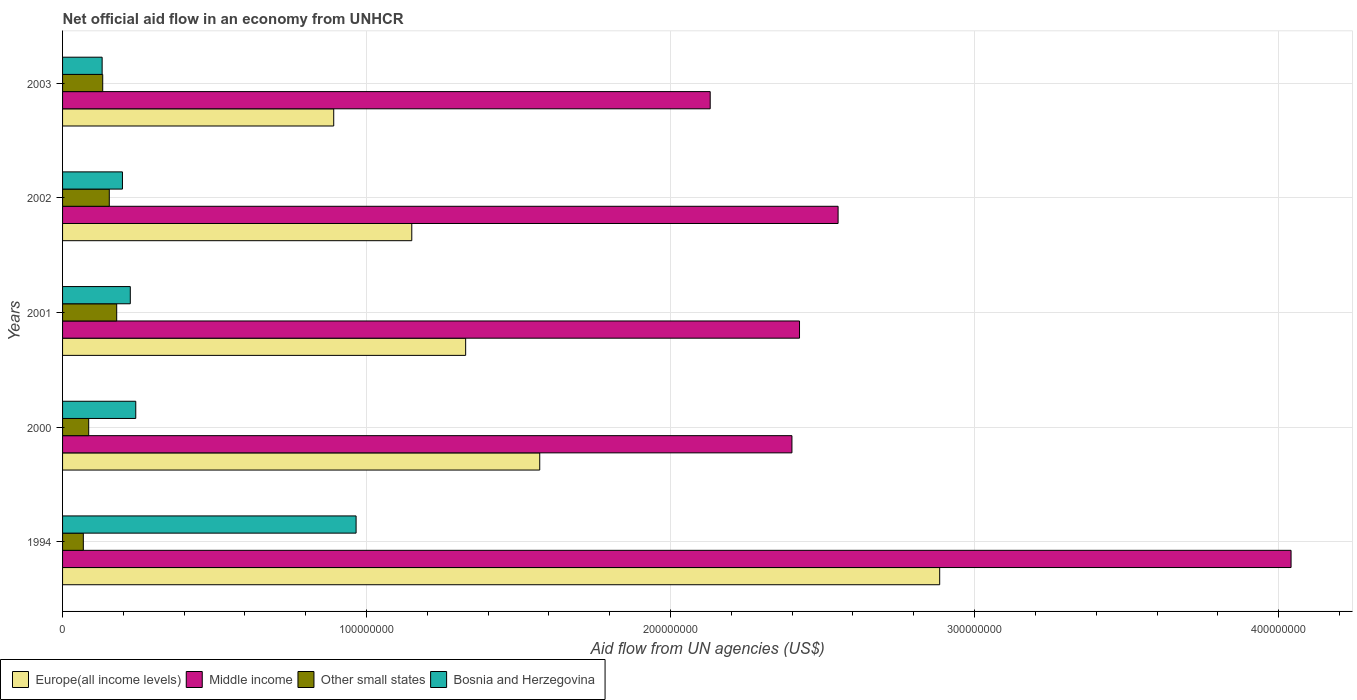How many different coloured bars are there?
Your answer should be compact. 4. In how many cases, is the number of bars for a given year not equal to the number of legend labels?
Offer a terse response. 0. What is the net official aid flow in Middle income in 2000?
Your response must be concise. 2.40e+08. Across all years, what is the maximum net official aid flow in Other small states?
Provide a short and direct response. 1.78e+07. Across all years, what is the minimum net official aid flow in Other small states?
Offer a terse response. 6.83e+06. In which year was the net official aid flow in Europe(all income levels) maximum?
Your answer should be very brief. 1994. In which year was the net official aid flow in Bosnia and Herzegovina minimum?
Your answer should be very brief. 2003. What is the total net official aid flow in Other small states in the graph?
Your answer should be very brief. 6.18e+07. What is the difference between the net official aid flow in Other small states in 1994 and that in 2003?
Your answer should be compact. -6.38e+06. What is the difference between the net official aid flow in Europe(all income levels) in 2000 and the net official aid flow in Middle income in 2002?
Offer a terse response. -9.81e+07. What is the average net official aid flow in Europe(all income levels) per year?
Offer a terse response. 1.56e+08. In the year 2001, what is the difference between the net official aid flow in Middle income and net official aid flow in Bosnia and Herzegovina?
Your answer should be very brief. 2.20e+08. In how many years, is the net official aid flow in Other small states greater than 280000000 US$?
Offer a terse response. 0. What is the ratio of the net official aid flow in Bosnia and Herzegovina in 2001 to that in 2003?
Keep it short and to the point. 1.71. Is the net official aid flow in Other small states in 2000 less than that in 2003?
Your response must be concise. Yes. Is the difference between the net official aid flow in Middle income in 2002 and 2003 greater than the difference between the net official aid flow in Bosnia and Herzegovina in 2002 and 2003?
Provide a succinct answer. Yes. What is the difference between the highest and the second highest net official aid flow in Bosnia and Herzegovina?
Ensure brevity in your answer.  7.25e+07. What is the difference between the highest and the lowest net official aid flow in Europe(all income levels)?
Keep it short and to the point. 1.99e+08. In how many years, is the net official aid flow in Europe(all income levels) greater than the average net official aid flow in Europe(all income levels) taken over all years?
Keep it short and to the point. 2. Is it the case that in every year, the sum of the net official aid flow in Bosnia and Herzegovina and net official aid flow in Other small states is greater than the sum of net official aid flow in Europe(all income levels) and net official aid flow in Middle income?
Provide a succinct answer. No. What does the 1st bar from the top in 1994 represents?
Offer a very short reply. Bosnia and Herzegovina. What does the 4th bar from the bottom in 2003 represents?
Offer a terse response. Bosnia and Herzegovina. Is it the case that in every year, the sum of the net official aid flow in Europe(all income levels) and net official aid flow in Other small states is greater than the net official aid flow in Middle income?
Give a very brief answer. No. How many bars are there?
Your answer should be compact. 20. Are all the bars in the graph horizontal?
Your answer should be compact. Yes. Does the graph contain any zero values?
Give a very brief answer. No. Does the graph contain grids?
Provide a short and direct response. Yes. What is the title of the graph?
Offer a terse response. Net official aid flow in an economy from UNHCR. Does "Equatorial Guinea" appear as one of the legend labels in the graph?
Give a very brief answer. No. What is the label or title of the X-axis?
Ensure brevity in your answer.  Aid flow from UN agencies (US$). What is the label or title of the Y-axis?
Make the answer very short. Years. What is the Aid flow from UN agencies (US$) in Europe(all income levels) in 1994?
Your answer should be very brief. 2.89e+08. What is the Aid flow from UN agencies (US$) in Middle income in 1994?
Keep it short and to the point. 4.04e+08. What is the Aid flow from UN agencies (US$) in Other small states in 1994?
Your answer should be compact. 6.83e+06. What is the Aid flow from UN agencies (US$) of Bosnia and Herzegovina in 1994?
Your answer should be very brief. 9.66e+07. What is the Aid flow from UN agencies (US$) in Europe(all income levels) in 2000?
Provide a short and direct response. 1.57e+08. What is the Aid flow from UN agencies (US$) in Middle income in 2000?
Provide a succinct answer. 2.40e+08. What is the Aid flow from UN agencies (US$) in Other small states in 2000?
Your answer should be compact. 8.60e+06. What is the Aid flow from UN agencies (US$) of Bosnia and Herzegovina in 2000?
Offer a terse response. 2.41e+07. What is the Aid flow from UN agencies (US$) of Europe(all income levels) in 2001?
Offer a terse response. 1.33e+08. What is the Aid flow from UN agencies (US$) of Middle income in 2001?
Your answer should be compact. 2.42e+08. What is the Aid flow from UN agencies (US$) in Other small states in 2001?
Give a very brief answer. 1.78e+07. What is the Aid flow from UN agencies (US$) of Bosnia and Herzegovina in 2001?
Keep it short and to the point. 2.23e+07. What is the Aid flow from UN agencies (US$) of Europe(all income levels) in 2002?
Keep it short and to the point. 1.15e+08. What is the Aid flow from UN agencies (US$) of Middle income in 2002?
Keep it short and to the point. 2.55e+08. What is the Aid flow from UN agencies (US$) of Other small states in 2002?
Provide a short and direct response. 1.54e+07. What is the Aid flow from UN agencies (US$) of Bosnia and Herzegovina in 2002?
Provide a short and direct response. 1.97e+07. What is the Aid flow from UN agencies (US$) of Europe(all income levels) in 2003?
Offer a very short reply. 8.92e+07. What is the Aid flow from UN agencies (US$) in Middle income in 2003?
Make the answer very short. 2.13e+08. What is the Aid flow from UN agencies (US$) of Other small states in 2003?
Give a very brief answer. 1.32e+07. What is the Aid flow from UN agencies (US$) in Bosnia and Herzegovina in 2003?
Your answer should be compact. 1.30e+07. Across all years, what is the maximum Aid flow from UN agencies (US$) in Europe(all income levels)?
Keep it short and to the point. 2.89e+08. Across all years, what is the maximum Aid flow from UN agencies (US$) of Middle income?
Your response must be concise. 4.04e+08. Across all years, what is the maximum Aid flow from UN agencies (US$) in Other small states?
Keep it short and to the point. 1.78e+07. Across all years, what is the maximum Aid flow from UN agencies (US$) in Bosnia and Herzegovina?
Your answer should be very brief. 9.66e+07. Across all years, what is the minimum Aid flow from UN agencies (US$) in Europe(all income levels)?
Give a very brief answer. 8.92e+07. Across all years, what is the minimum Aid flow from UN agencies (US$) in Middle income?
Your answer should be compact. 2.13e+08. Across all years, what is the minimum Aid flow from UN agencies (US$) of Other small states?
Make the answer very short. 6.83e+06. Across all years, what is the minimum Aid flow from UN agencies (US$) of Bosnia and Herzegovina?
Give a very brief answer. 1.30e+07. What is the total Aid flow from UN agencies (US$) of Europe(all income levels) in the graph?
Your response must be concise. 7.82e+08. What is the total Aid flow from UN agencies (US$) of Middle income in the graph?
Your answer should be compact. 1.35e+09. What is the total Aid flow from UN agencies (US$) in Other small states in the graph?
Your answer should be compact. 6.18e+07. What is the total Aid flow from UN agencies (US$) of Bosnia and Herzegovina in the graph?
Offer a very short reply. 1.76e+08. What is the difference between the Aid flow from UN agencies (US$) in Europe(all income levels) in 1994 and that in 2000?
Your answer should be very brief. 1.32e+08. What is the difference between the Aid flow from UN agencies (US$) in Middle income in 1994 and that in 2000?
Ensure brevity in your answer.  1.64e+08. What is the difference between the Aid flow from UN agencies (US$) of Other small states in 1994 and that in 2000?
Ensure brevity in your answer.  -1.77e+06. What is the difference between the Aid flow from UN agencies (US$) in Bosnia and Herzegovina in 1994 and that in 2000?
Your answer should be compact. 7.25e+07. What is the difference between the Aid flow from UN agencies (US$) of Europe(all income levels) in 1994 and that in 2001?
Provide a short and direct response. 1.56e+08. What is the difference between the Aid flow from UN agencies (US$) in Middle income in 1994 and that in 2001?
Your answer should be very brief. 1.62e+08. What is the difference between the Aid flow from UN agencies (US$) of Other small states in 1994 and that in 2001?
Your answer should be compact. -1.10e+07. What is the difference between the Aid flow from UN agencies (US$) in Bosnia and Herzegovina in 1994 and that in 2001?
Give a very brief answer. 7.43e+07. What is the difference between the Aid flow from UN agencies (US$) of Europe(all income levels) in 1994 and that in 2002?
Your answer should be very brief. 1.74e+08. What is the difference between the Aid flow from UN agencies (US$) of Middle income in 1994 and that in 2002?
Your answer should be very brief. 1.49e+08. What is the difference between the Aid flow from UN agencies (US$) in Other small states in 1994 and that in 2002?
Your response must be concise. -8.54e+06. What is the difference between the Aid flow from UN agencies (US$) of Bosnia and Herzegovina in 1994 and that in 2002?
Offer a very short reply. 7.68e+07. What is the difference between the Aid flow from UN agencies (US$) of Europe(all income levels) in 1994 and that in 2003?
Make the answer very short. 1.99e+08. What is the difference between the Aid flow from UN agencies (US$) of Middle income in 1994 and that in 2003?
Offer a very short reply. 1.91e+08. What is the difference between the Aid flow from UN agencies (US$) of Other small states in 1994 and that in 2003?
Provide a succinct answer. -6.38e+06. What is the difference between the Aid flow from UN agencies (US$) of Bosnia and Herzegovina in 1994 and that in 2003?
Offer a terse response. 8.35e+07. What is the difference between the Aid flow from UN agencies (US$) of Europe(all income levels) in 2000 and that in 2001?
Make the answer very short. 2.44e+07. What is the difference between the Aid flow from UN agencies (US$) of Middle income in 2000 and that in 2001?
Your answer should be compact. -2.49e+06. What is the difference between the Aid flow from UN agencies (US$) of Other small states in 2000 and that in 2001?
Make the answer very short. -9.21e+06. What is the difference between the Aid flow from UN agencies (US$) of Bosnia and Herzegovina in 2000 and that in 2001?
Provide a succinct answer. 1.80e+06. What is the difference between the Aid flow from UN agencies (US$) in Europe(all income levels) in 2000 and that in 2002?
Your answer should be very brief. 4.21e+07. What is the difference between the Aid flow from UN agencies (US$) in Middle income in 2000 and that in 2002?
Keep it short and to the point. -1.52e+07. What is the difference between the Aid flow from UN agencies (US$) of Other small states in 2000 and that in 2002?
Your answer should be very brief. -6.77e+06. What is the difference between the Aid flow from UN agencies (US$) of Bosnia and Herzegovina in 2000 and that in 2002?
Keep it short and to the point. 4.38e+06. What is the difference between the Aid flow from UN agencies (US$) in Europe(all income levels) in 2000 and that in 2003?
Provide a short and direct response. 6.78e+07. What is the difference between the Aid flow from UN agencies (US$) in Middle income in 2000 and that in 2003?
Give a very brief answer. 2.69e+07. What is the difference between the Aid flow from UN agencies (US$) of Other small states in 2000 and that in 2003?
Keep it short and to the point. -4.61e+06. What is the difference between the Aid flow from UN agencies (US$) of Bosnia and Herzegovina in 2000 and that in 2003?
Keep it short and to the point. 1.11e+07. What is the difference between the Aid flow from UN agencies (US$) of Europe(all income levels) in 2001 and that in 2002?
Keep it short and to the point. 1.77e+07. What is the difference between the Aid flow from UN agencies (US$) in Middle income in 2001 and that in 2002?
Your response must be concise. -1.27e+07. What is the difference between the Aid flow from UN agencies (US$) of Other small states in 2001 and that in 2002?
Offer a terse response. 2.44e+06. What is the difference between the Aid flow from UN agencies (US$) of Bosnia and Herzegovina in 2001 and that in 2002?
Offer a very short reply. 2.58e+06. What is the difference between the Aid flow from UN agencies (US$) in Europe(all income levels) in 2001 and that in 2003?
Offer a very short reply. 4.34e+07. What is the difference between the Aid flow from UN agencies (US$) in Middle income in 2001 and that in 2003?
Give a very brief answer. 2.94e+07. What is the difference between the Aid flow from UN agencies (US$) of Other small states in 2001 and that in 2003?
Your answer should be very brief. 4.60e+06. What is the difference between the Aid flow from UN agencies (US$) in Bosnia and Herzegovina in 2001 and that in 2003?
Ensure brevity in your answer.  9.26e+06. What is the difference between the Aid flow from UN agencies (US$) in Europe(all income levels) in 2002 and that in 2003?
Your answer should be very brief. 2.57e+07. What is the difference between the Aid flow from UN agencies (US$) of Middle income in 2002 and that in 2003?
Your response must be concise. 4.21e+07. What is the difference between the Aid flow from UN agencies (US$) of Other small states in 2002 and that in 2003?
Keep it short and to the point. 2.16e+06. What is the difference between the Aid flow from UN agencies (US$) in Bosnia and Herzegovina in 2002 and that in 2003?
Give a very brief answer. 6.68e+06. What is the difference between the Aid flow from UN agencies (US$) of Europe(all income levels) in 1994 and the Aid flow from UN agencies (US$) of Middle income in 2000?
Give a very brief answer. 4.86e+07. What is the difference between the Aid flow from UN agencies (US$) in Europe(all income levels) in 1994 and the Aid flow from UN agencies (US$) in Other small states in 2000?
Give a very brief answer. 2.80e+08. What is the difference between the Aid flow from UN agencies (US$) of Europe(all income levels) in 1994 and the Aid flow from UN agencies (US$) of Bosnia and Herzegovina in 2000?
Your response must be concise. 2.64e+08. What is the difference between the Aid flow from UN agencies (US$) in Middle income in 1994 and the Aid flow from UN agencies (US$) in Other small states in 2000?
Provide a short and direct response. 3.96e+08. What is the difference between the Aid flow from UN agencies (US$) in Middle income in 1994 and the Aid flow from UN agencies (US$) in Bosnia and Herzegovina in 2000?
Provide a succinct answer. 3.80e+08. What is the difference between the Aid flow from UN agencies (US$) of Other small states in 1994 and the Aid flow from UN agencies (US$) of Bosnia and Herzegovina in 2000?
Keep it short and to the point. -1.72e+07. What is the difference between the Aid flow from UN agencies (US$) of Europe(all income levels) in 1994 and the Aid flow from UN agencies (US$) of Middle income in 2001?
Provide a succinct answer. 4.61e+07. What is the difference between the Aid flow from UN agencies (US$) in Europe(all income levels) in 1994 and the Aid flow from UN agencies (US$) in Other small states in 2001?
Offer a very short reply. 2.71e+08. What is the difference between the Aid flow from UN agencies (US$) of Europe(all income levels) in 1994 and the Aid flow from UN agencies (US$) of Bosnia and Herzegovina in 2001?
Give a very brief answer. 2.66e+08. What is the difference between the Aid flow from UN agencies (US$) of Middle income in 1994 and the Aid flow from UN agencies (US$) of Other small states in 2001?
Give a very brief answer. 3.86e+08. What is the difference between the Aid flow from UN agencies (US$) of Middle income in 1994 and the Aid flow from UN agencies (US$) of Bosnia and Herzegovina in 2001?
Your response must be concise. 3.82e+08. What is the difference between the Aid flow from UN agencies (US$) in Other small states in 1994 and the Aid flow from UN agencies (US$) in Bosnia and Herzegovina in 2001?
Give a very brief answer. -1.54e+07. What is the difference between the Aid flow from UN agencies (US$) of Europe(all income levels) in 1994 and the Aid flow from UN agencies (US$) of Middle income in 2002?
Keep it short and to the point. 3.34e+07. What is the difference between the Aid flow from UN agencies (US$) of Europe(all income levels) in 1994 and the Aid flow from UN agencies (US$) of Other small states in 2002?
Your response must be concise. 2.73e+08. What is the difference between the Aid flow from UN agencies (US$) in Europe(all income levels) in 1994 and the Aid flow from UN agencies (US$) in Bosnia and Herzegovina in 2002?
Your response must be concise. 2.69e+08. What is the difference between the Aid flow from UN agencies (US$) of Middle income in 1994 and the Aid flow from UN agencies (US$) of Other small states in 2002?
Keep it short and to the point. 3.89e+08. What is the difference between the Aid flow from UN agencies (US$) of Middle income in 1994 and the Aid flow from UN agencies (US$) of Bosnia and Herzegovina in 2002?
Offer a very short reply. 3.84e+08. What is the difference between the Aid flow from UN agencies (US$) of Other small states in 1994 and the Aid flow from UN agencies (US$) of Bosnia and Herzegovina in 2002?
Provide a short and direct response. -1.29e+07. What is the difference between the Aid flow from UN agencies (US$) of Europe(all income levels) in 1994 and the Aid flow from UN agencies (US$) of Middle income in 2003?
Your answer should be compact. 7.55e+07. What is the difference between the Aid flow from UN agencies (US$) of Europe(all income levels) in 1994 and the Aid flow from UN agencies (US$) of Other small states in 2003?
Ensure brevity in your answer.  2.75e+08. What is the difference between the Aid flow from UN agencies (US$) in Europe(all income levels) in 1994 and the Aid flow from UN agencies (US$) in Bosnia and Herzegovina in 2003?
Offer a terse response. 2.76e+08. What is the difference between the Aid flow from UN agencies (US$) in Middle income in 1994 and the Aid flow from UN agencies (US$) in Other small states in 2003?
Make the answer very short. 3.91e+08. What is the difference between the Aid flow from UN agencies (US$) of Middle income in 1994 and the Aid flow from UN agencies (US$) of Bosnia and Herzegovina in 2003?
Give a very brief answer. 3.91e+08. What is the difference between the Aid flow from UN agencies (US$) in Other small states in 1994 and the Aid flow from UN agencies (US$) in Bosnia and Herzegovina in 2003?
Provide a short and direct response. -6.19e+06. What is the difference between the Aid flow from UN agencies (US$) in Europe(all income levels) in 2000 and the Aid flow from UN agencies (US$) in Middle income in 2001?
Ensure brevity in your answer.  -8.54e+07. What is the difference between the Aid flow from UN agencies (US$) of Europe(all income levels) in 2000 and the Aid flow from UN agencies (US$) of Other small states in 2001?
Ensure brevity in your answer.  1.39e+08. What is the difference between the Aid flow from UN agencies (US$) of Europe(all income levels) in 2000 and the Aid flow from UN agencies (US$) of Bosnia and Herzegovina in 2001?
Your answer should be very brief. 1.35e+08. What is the difference between the Aid flow from UN agencies (US$) in Middle income in 2000 and the Aid flow from UN agencies (US$) in Other small states in 2001?
Your response must be concise. 2.22e+08. What is the difference between the Aid flow from UN agencies (US$) in Middle income in 2000 and the Aid flow from UN agencies (US$) in Bosnia and Herzegovina in 2001?
Your answer should be compact. 2.18e+08. What is the difference between the Aid flow from UN agencies (US$) of Other small states in 2000 and the Aid flow from UN agencies (US$) of Bosnia and Herzegovina in 2001?
Give a very brief answer. -1.37e+07. What is the difference between the Aid flow from UN agencies (US$) of Europe(all income levels) in 2000 and the Aid flow from UN agencies (US$) of Middle income in 2002?
Provide a succinct answer. -9.81e+07. What is the difference between the Aid flow from UN agencies (US$) of Europe(all income levels) in 2000 and the Aid flow from UN agencies (US$) of Other small states in 2002?
Make the answer very short. 1.42e+08. What is the difference between the Aid flow from UN agencies (US$) of Europe(all income levels) in 2000 and the Aid flow from UN agencies (US$) of Bosnia and Herzegovina in 2002?
Provide a short and direct response. 1.37e+08. What is the difference between the Aid flow from UN agencies (US$) in Middle income in 2000 and the Aid flow from UN agencies (US$) in Other small states in 2002?
Ensure brevity in your answer.  2.25e+08. What is the difference between the Aid flow from UN agencies (US$) of Middle income in 2000 and the Aid flow from UN agencies (US$) of Bosnia and Herzegovina in 2002?
Make the answer very short. 2.20e+08. What is the difference between the Aid flow from UN agencies (US$) of Other small states in 2000 and the Aid flow from UN agencies (US$) of Bosnia and Herzegovina in 2002?
Your answer should be compact. -1.11e+07. What is the difference between the Aid flow from UN agencies (US$) in Europe(all income levels) in 2000 and the Aid flow from UN agencies (US$) in Middle income in 2003?
Give a very brief answer. -5.61e+07. What is the difference between the Aid flow from UN agencies (US$) of Europe(all income levels) in 2000 and the Aid flow from UN agencies (US$) of Other small states in 2003?
Offer a terse response. 1.44e+08. What is the difference between the Aid flow from UN agencies (US$) of Europe(all income levels) in 2000 and the Aid flow from UN agencies (US$) of Bosnia and Herzegovina in 2003?
Your answer should be compact. 1.44e+08. What is the difference between the Aid flow from UN agencies (US$) in Middle income in 2000 and the Aid flow from UN agencies (US$) in Other small states in 2003?
Provide a succinct answer. 2.27e+08. What is the difference between the Aid flow from UN agencies (US$) in Middle income in 2000 and the Aid flow from UN agencies (US$) in Bosnia and Herzegovina in 2003?
Ensure brevity in your answer.  2.27e+08. What is the difference between the Aid flow from UN agencies (US$) in Other small states in 2000 and the Aid flow from UN agencies (US$) in Bosnia and Herzegovina in 2003?
Provide a short and direct response. -4.42e+06. What is the difference between the Aid flow from UN agencies (US$) in Europe(all income levels) in 2001 and the Aid flow from UN agencies (US$) in Middle income in 2002?
Keep it short and to the point. -1.23e+08. What is the difference between the Aid flow from UN agencies (US$) in Europe(all income levels) in 2001 and the Aid flow from UN agencies (US$) in Other small states in 2002?
Your response must be concise. 1.17e+08. What is the difference between the Aid flow from UN agencies (US$) of Europe(all income levels) in 2001 and the Aid flow from UN agencies (US$) of Bosnia and Herzegovina in 2002?
Give a very brief answer. 1.13e+08. What is the difference between the Aid flow from UN agencies (US$) of Middle income in 2001 and the Aid flow from UN agencies (US$) of Other small states in 2002?
Ensure brevity in your answer.  2.27e+08. What is the difference between the Aid flow from UN agencies (US$) of Middle income in 2001 and the Aid flow from UN agencies (US$) of Bosnia and Herzegovina in 2002?
Provide a succinct answer. 2.23e+08. What is the difference between the Aid flow from UN agencies (US$) in Other small states in 2001 and the Aid flow from UN agencies (US$) in Bosnia and Herzegovina in 2002?
Your answer should be very brief. -1.89e+06. What is the difference between the Aid flow from UN agencies (US$) in Europe(all income levels) in 2001 and the Aid flow from UN agencies (US$) in Middle income in 2003?
Give a very brief answer. -8.04e+07. What is the difference between the Aid flow from UN agencies (US$) of Europe(all income levels) in 2001 and the Aid flow from UN agencies (US$) of Other small states in 2003?
Your answer should be compact. 1.19e+08. What is the difference between the Aid flow from UN agencies (US$) of Europe(all income levels) in 2001 and the Aid flow from UN agencies (US$) of Bosnia and Herzegovina in 2003?
Your answer should be compact. 1.20e+08. What is the difference between the Aid flow from UN agencies (US$) of Middle income in 2001 and the Aid flow from UN agencies (US$) of Other small states in 2003?
Make the answer very short. 2.29e+08. What is the difference between the Aid flow from UN agencies (US$) in Middle income in 2001 and the Aid flow from UN agencies (US$) in Bosnia and Herzegovina in 2003?
Give a very brief answer. 2.29e+08. What is the difference between the Aid flow from UN agencies (US$) of Other small states in 2001 and the Aid flow from UN agencies (US$) of Bosnia and Herzegovina in 2003?
Give a very brief answer. 4.79e+06. What is the difference between the Aid flow from UN agencies (US$) of Europe(all income levels) in 2002 and the Aid flow from UN agencies (US$) of Middle income in 2003?
Give a very brief answer. -9.82e+07. What is the difference between the Aid flow from UN agencies (US$) in Europe(all income levels) in 2002 and the Aid flow from UN agencies (US$) in Other small states in 2003?
Offer a very short reply. 1.02e+08. What is the difference between the Aid flow from UN agencies (US$) of Europe(all income levels) in 2002 and the Aid flow from UN agencies (US$) of Bosnia and Herzegovina in 2003?
Give a very brief answer. 1.02e+08. What is the difference between the Aid flow from UN agencies (US$) of Middle income in 2002 and the Aid flow from UN agencies (US$) of Other small states in 2003?
Keep it short and to the point. 2.42e+08. What is the difference between the Aid flow from UN agencies (US$) of Middle income in 2002 and the Aid flow from UN agencies (US$) of Bosnia and Herzegovina in 2003?
Give a very brief answer. 2.42e+08. What is the difference between the Aid flow from UN agencies (US$) of Other small states in 2002 and the Aid flow from UN agencies (US$) of Bosnia and Herzegovina in 2003?
Ensure brevity in your answer.  2.35e+06. What is the average Aid flow from UN agencies (US$) of Europe(all income levels) per year?
Provide a short and direct response. 1.56e+08. What is the average Aid flow from UN agencies (US$) of Middle income per year?
Offer a terse response. 2.71e+08. What is the average Aid flow from UN agencies (US$) in Other small states per year?
Offer a very short reply. 1.24e+07. What is the average Aid flow from UN agencies (US$) of Bosnia and Herzegovina per year?
Keep it short and to the point. 3.51e+07. In the year 1994, what is the difference between the Aid flow from UN agencies (US$) in Europe(all income levels) and Aid flow from UN agencies (US$) in Middle income?
Give a very brief answer. -1.16e+08. In the year 1994, what is the difference between the Aid flow from UN agencies (US$) of Europe(all income levels) and Aid flow from UN agencies (US$) of Other small states?
Keep it short and to the point. 2.82e+08. In the year 1994, what is the difference between the Aid flow from UN agencies (US$) of Europe(all income levels) and Aid flow from UN agencies (US$) of Bosnia and Herzegovina?
Provide a succinct answer. 1.92e+08. In the year 1994, what is the difference between the Aid flow from UN agencies (US$) of Middle income and Aid flow from UN agencies (US$) of Other small states?
Make the answer very short. 3.97e+08. In the year 1994, what is the difference between the Aid flow from UN agencies (US$) in Middle income and Aid flow from UN agencies (US$) in Bosnia and Herzegovina?
Your answer should be very brief. 3.08e+08. In the year 1994, what is the difference between the Aid flow from UN agencies (US$) of Other small states and Aid flow from UN agencies (US$) of Bosnia and Herzegovina?
Make the answer very short. -8.97e+07. In the year 2000, what is the difference between the Aid flow from UN agencies (US$) of Europe(all income levels) and Aid flow from UN agencies (US$) of Middle income?
Provide a succinct answer. -8.30e+07. In the year 2000, what is the difference between the Aid flow from UN agencies (US$) in Europe(all income levels) and Aid flow from UN agencies (US$) in Other small states?
Offer a terse response. 1.48e+08. In the year 2000, what is the difference between the Aid flow from UN agencies (US$) in Europe(all income levels) and Aid flow from UN agencies (US$) in Bosnia and Herzegovina?
Make the answer very short. 1.33e+08. In the year 2000, what is the difference between the Aid flow from UN agencies (US$) of Middle income and Aid flow from UN agencies (US$) of Other small states?
Offer a very short reply. 2.31e+08. In the year 2000, what is the difference between the Aid flow from UN agencies (US$) of Middle income and Aid flow from UN agencies (US$) of Bosnia and Herzegovina?
Make the answer very short. 2.16e+08. In the year 2000, what is the difference between the Aid flow from UN agencies (US$) of Other small states and Aid flow from UN agencies (US$) of Bosnia and Herzegovina?
Ensure brevity in your answer.  -1.55e+07. In the year 2001, what is the difference between the Aid flow from UN agencies (US$) in Europe(all income levels) and Aid flow from UN agencies (US$) in Middle income?
Your answer should be compact. -1.10e+08. In the year 2001, what is the difference between the Aid flow from UN agencies (US$) of Europe(all income levels) and Aid flow from UN agencies (US$) of Other small states?
Your answer should be very brief. 1.15e+08. In the year 2001, what is the difference between the Aid flow from UN agencies (US$) in Europe(all income levels) and Aid flow from UN agencies (US$) in Bosnia and Herzegovina?
Provide a short and direct response. 1.10e+08. In the year 2001, what is the difference between the Aid flow from UN agencies (US$) of Middle income and Aid flow from UN agencies (US$) of Other small states?
Your answer should be very brief. 2.25e+08. In the year 2001, what is the difference between the Aid flow from UN agencies (US$) of Middle income and Aid flow from UN agencies (US$) of Bosnia and Herzegovina?
Keep it short and to the point. 2.20e+08. In the year 2001, what is the difference between the Aid flow from UN agencies (US$) of Other small states and Aid flow from UN agencies (US$) of Bosnia and Herzegovina?
Offer a very short reply. -4.47e+06. In the year 2002, what is the difference between the Aid flow from UN agencies (US$) in Europe(all income levels) and Aid flow from UN agencies (US$) in Middle income?
Your response must be concise. -1.40e+08. In the year 2002, what is the difference between the Aid flow from UN agencies (US$) in Europe(all income levels) and Aid flow from UN agencies (US$) in Other small states?
Your answer should be compact. 9.95e+07. In the year 2002, what is the difference between the Aid flow from UN agencies (US$) of Europe(all income levels) and Aid flow from UN agencies (US$) of Bosnia and Herzegovina?
Make the answer very short. 9.52e+07. In the year 2002, what is the difference between the Aid flow from UN agencies (US$) in Middle income and Aid flow from UN agencies (US$) in Other small states?
Provide a succinct answer. 2.40e+08. In the year 2002, what is the difference between the Aid flow from UN agencies (US$) in Middle income and Aid flow from UN agencies (US$) in Bosnia and Herzegovina?
Your response must be concise. 2.35e+08. In the year 2002, what is the difference between the Aid flow from UN agencies (US$) of Other small states and Aid flow from UN agencies (US$) of Bosnia and Herzegovina?
Offer a very short reply. -4.33e+06. In the year 2003, what is the difference between the Aid flow from UN agencies (US$) in Europe(all income levels) and Aid flow from UN agencies (US$) in Middle income?
Ensure brevity in your answer.  -1.24e+08. In the year 2003, what is the difference between the Aid flow from UN agencies (US$) of Europe(all income levels) and Aid flow from UN agencies (US$) of Other small states?
Your answer should be compact. 7.60e+07. In the year 2003, what is the difference between the Aid flow from UN agencies (US$) in Europe(all income levels) and Aid flow from UN agencies (US$) in Bosnia and Herzegovina?
Give a very brief answer. 7.62e+07. In the year 2003, what is the difference between the Aid flow from UN agencies (US$) of Middle income and Aid flow from UN agencies (US$) of Other small states?
Your answer should be very brief. 2.00e+08. In the year 2003, what is the difference between the Aid flow from UN agencies (US$) in Middle income and Aid flow from UN agencies (US$) in Bosnia and Herzegovina?
Give a very brief answer. 2.00e+08. In the year 2003, what is the difference between the Aid flow from UN agencies (US$) in Other small states and Aid flow from UN agencies (US$) in Bosnia and Herzegovina?
Your response must be concise. 1.90e+05. What is the ratio of the Aid flow from UN agencies (US$) of Europe(all income levels) in 1994 to that in 2000?
Ensure brevity in your answer.  1.84. What is the ratio of the Aid flow from UN agencies (US$) in Middle income in 1994 to that in 2000?
Keep it short and to the point. 1.68. What is the ratio of the Aid flow from UN agencies (US$) in Other small states in 1994 to that in 2000?
Your answer should be compact. 0.79. What is the ratio of the Aid flow from UN agencies (US$) of Bosnia and Herzegovina in 1994 to that in 2000?
Ensure brevity in your answer.  4.01. What is the ratio of the Aid flow from UN agencies (US$) in Europe(all income levels) in 1994 to that in 2001?
Provide a succinct answer. 2.18. What is the ratio of the Aid flow from UN agencies (US$) in Middle income in 1994 to that in 2001?
Offer a very short reply. 1.67. What is the ratio of the Aid flow from UN agencies (US$) of Other small states in 1994 to that in 2001?
Keep it short and to the point. 0.38. What is the ratio of the Aid flow from UN agencies (US$) in Bosnia and Herzegovina in 1994 to that in 2001?
Keep it short and to the point. 4.33. What is the ratio of the Aid flow from UN agencies (US$) of Europe(all income levels) in 1994 to that in 2002?
Provide a succinct answer. 2.51. What is the ratio of the Aid flow from UN agencies (US$) in Middle income in 1994 to that in 2002?
Provide a short and direct response. 1.58. What is the ratio of the Aid flow from UN agencies (US$) in Other small states in 1994 to that in 2002?
Give a very brief answer. 0.44. What is the ratio of the Aid flow from UN agencies (US$) in Bosnia and Herzegovina in 1994 to that in 2002?
Offer a very short reply. 4.9. What is the ratio of the Aid flow from UN agencies (US$) of Europe(all income levels) in 1994 to that in 2003?
Your answer should be very brief. 3.23. What is the ratio of the Aid flow from UN agencies (US$) of Middle income in 1994 to that in 2003?
Your answer should be compact. 1.9. What is the ratio of the Aid flow from UN agencies (US$) in Other small states in 1994 to that in 2003?
Keep it short and to the point. 0.52. What is the ratio of the Aid flow from UN agencies (US$) of Bosnia and Herzegovina in 1994 to that in 2003?
Make the answer very short. 7.42. What is the ratio of the Aid flow from UN agencies (US$) of Europe(all income levels) in 2000 to that in 2001?
Offer a very short reply. 1.18. What is the ratio of the Aid flow from UN agencies (US$) in Other small states in 2000 to that in 2001?
Provide a short and direct response. 0.48. What is the ratio of the Aid flow from UN agencies (US$) in Bosnia and Herzegovina in 2000 to that in 2001?
Your answer should be compact. 1.08. What is the ratio of the Aid flow from UN agencies (US$) in Europe(all income levels) in 2000 to that in 2002?
Keep it short and to the point. 1.37. What is the ratio of the Aid flow from UN agencies (US$) in Middle income in 2000 to that in 2002?
Offer a very short reply. 0.94. What is the ratio of the Aid flow from UN agencies (US$) of Other small states in 2000 to that in 2002?
Give a very brief answer. 0.56. What is the ratio of the Aid flow from UN agencies (US$) in Bosnia and Herzegovina in 2000 to that in 2002?
Offer a terse response. 1.22. What is the ratio of the Aid flow from UN agencies (US$) of Europe(all income levels) in 2000 to that in 2003?
Ensure brevity in your answer.  1.76. What is the ratio of the Aid flow from UN agencies (US$) of Middle income in 2000 to that in 2003?
Your answer should be very brief. 1.13. What is the ratio of the Aid flow from UN agencies (US$) of Other small states in 2000 to that in 2003?
Your answer should be very brief. 0.65. What is the ratio of the Aid flow from UN agencies (US$) in Bosnia and Herzegovina in 2000 to that in 2003?
Keep it short and to the point. 1.85. What is the ratio of the Aid flow from UN agencies (US$) of Europe(all income levels) in 2001 to that in 2002?
Your answer should be very brief. 1.15. What is the ratio of the Aid flow from UN agencies (US$) in Middle income in 2001 to that in 2002?
Your answer should be very brief. 0.95. What is the ratio of the Aid flow from UN agencies (US$) in Other small states in 2001 to that in 2002?
Your answer should be very brief. 1.16. What is the ratio of the Aid flow from UN agencies (US$) of Bosnia and Herzegovina in 2001 to that in 2002?
Give a very brief answer. 1.13. What is the ratio of the Aid flow from UN agencies (US$) in Europe(all income levels) in 2001 to that in 2003?
Provide a succinct answer. 1.49. What is the ratio of the Aid flow from UN agencies (US$) of Middle income in 2001 to that in 2003?
Provide a short and direct response. 1.14. What is the ratio of the Aid flow from UN agencies (US$) in Other small states in 2001 to that in 2003?
Give a very brief answer. 1.35. What is the ratio of the Aid flow from UN agencies (US$) of Bosnia and Herzegovina in 2001 to that in 2003?
Your response must be concise. 1.71. What is the ratio of the Aid flow from UN agencies (US$) of Europe(all income levels) in 2002 to that in 2003?
Your answer should be very brief. 1.29. What is the ratio of the Aid flow from UN agencies (US$) in Middle income in 2002 to that in 2003?
Keep it short and to the point. 1.2. What is the ratio of the Aid flow from UN agencies (US$) in Other small states in 2002 to that in 2003?
Provide a succinct answer. 1.16. What is the ratio of the Aid flow from UN agencies (US$) of Bosnia and Herzegovina in 2002 to that in 2003?
Your answer should be compact. 1.51. What is the difference between the highest and the second highest Aid flow from UN agencies (US$) of Europe(all income levels)?
Offer a terse response. 1.32e+08. What is the difference between the highest and the second highest Aid flow from UN agencies (US$) of Middle income?
Provide a succinct answer. 1.49e+08. What is the difference between the highest and the second highest Aid flow from UN agencies (US$) of Other small states?
Your answer should be very brief. 2.44e+06. What is the difference between the highest and the second highest Aid flow from UN agencies (US$) of Bosnia and Herzegovina?
Give a very brief answer. 7.25e+07. What is the difference between the highest and the lowest Aid flow from UN agencies (US$) of Europe(all income levels)?
Ensure brevity in your answer.  1.99e+08. What is the difference between the highest and the lowest Aid flow from UN agencies (US$) of Middle income?
Offer a very short reply. 1.91e+08. What is the difference between the highest and the lowest Aid flow from UN agencies (US$) of Other small states?
Make the answer very short. 1.10e+07. What is the difference between the highest and the lowest Aid flow from UN agencies (US$) of Bosnia and Herzegovina?
Your answer should be very brief. 8.35e+07. 